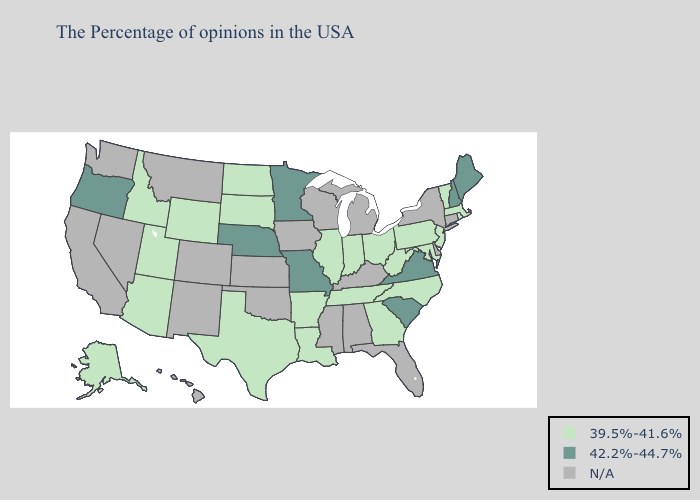Name the states that have a value in the range 42.2%-44.7%?
Concise answer only. Maine, New Hampshire, Virginia, South Carolina, Missouri, Minnesota, Nebraska, Oregon. What is the highest value in the Northeast ?
Keep it brief. 42.2%-44.7%. What is the highest value in the Northeast ?
Quick response, please. 42.2%-44.7%. What is the highest value in the West ?
Short answer required. 42.2%-44.7%. What is the value of Maine?
Answer briefly. 42.2%-44.7%. What is the value of North Carolina?
Short answer required. 39.5%-41.6%. Does Pennsylvania have the highest value in the Northeast?
Be succinct. No. What is the lowest value in states that border Nevada?
Concise answer only. 39.5%-41.6%. Which states have the highest value in the USA?
Keep it brief. Maine, New Hampshire, Virginia, South Carolina, Missouri, Minnesota, Nebraska, Oregon. What is the highest value in states that border Tennessee?
Be succinct. 42.2%-44.7%. Name the states that have a value in the range 42.2%-44.7%?
Answer briefly. Maine, New Hampshire, Virginia, South Carolina, Missouri, Minnesota, Nebraska, Oregon. What is the value of New Hampshire?
Concise answer only. 42.2%-44.7%. Name the states that have a value in the range N/A?
Be succinct. Connecticut, New York, Delaware, Florida, Michigan, Kentucky, Alabama, Wisconsin, Mississippi, Iowa, Kansas, Oklahoma, Colorado, New Mexico, Montana, Nevada, California, Washington, Hawaii. Name the states that have a value in the range 39.5%-41.6%?
Keep it brief. Massachusetts, Rhode Island, Vermont, New Jersey, Maryland, Pennsylvania, North Carolina, West Virginia, Ohio, Georgia, Indiana, Tennessee, Illinois, Louisiana, Arkansas, Texas, South Dakota, North Dakota, Wyoming, Utah, Arizona, Idaho, Alaska. 